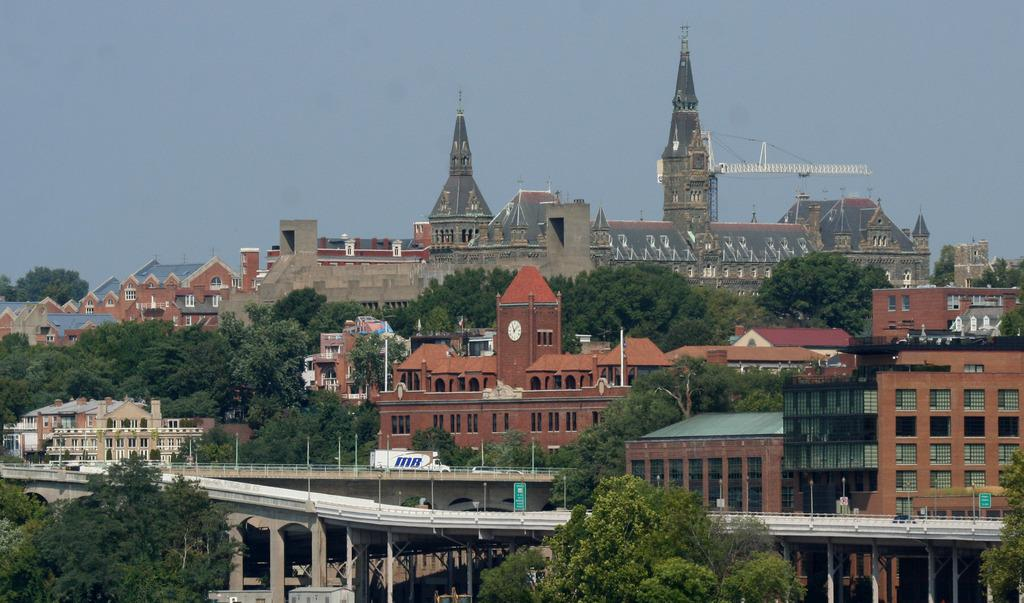What type of structures can be seen in the image? There are buildings in the image. What natural elements are present in the image? There are trees in the image. What type of man-made structure is visible in the image? There is a bridge in the image. What type of transportation is visible in the image? Motor vehicles are visible in the image. What architectural features can be seen in the image? There are pillars in the image. What type of urban infrastructure is present in the image? Street poles are present in the image. What type of lighting is visible in the image? Street lights are visible in the image. What part of the natural environment is visible in the image? The sky is visible in the image. What type of brick is used to construct the mine in the image? There is no mine present in the image, so it is not possible to determine the type of brick used for construction. 